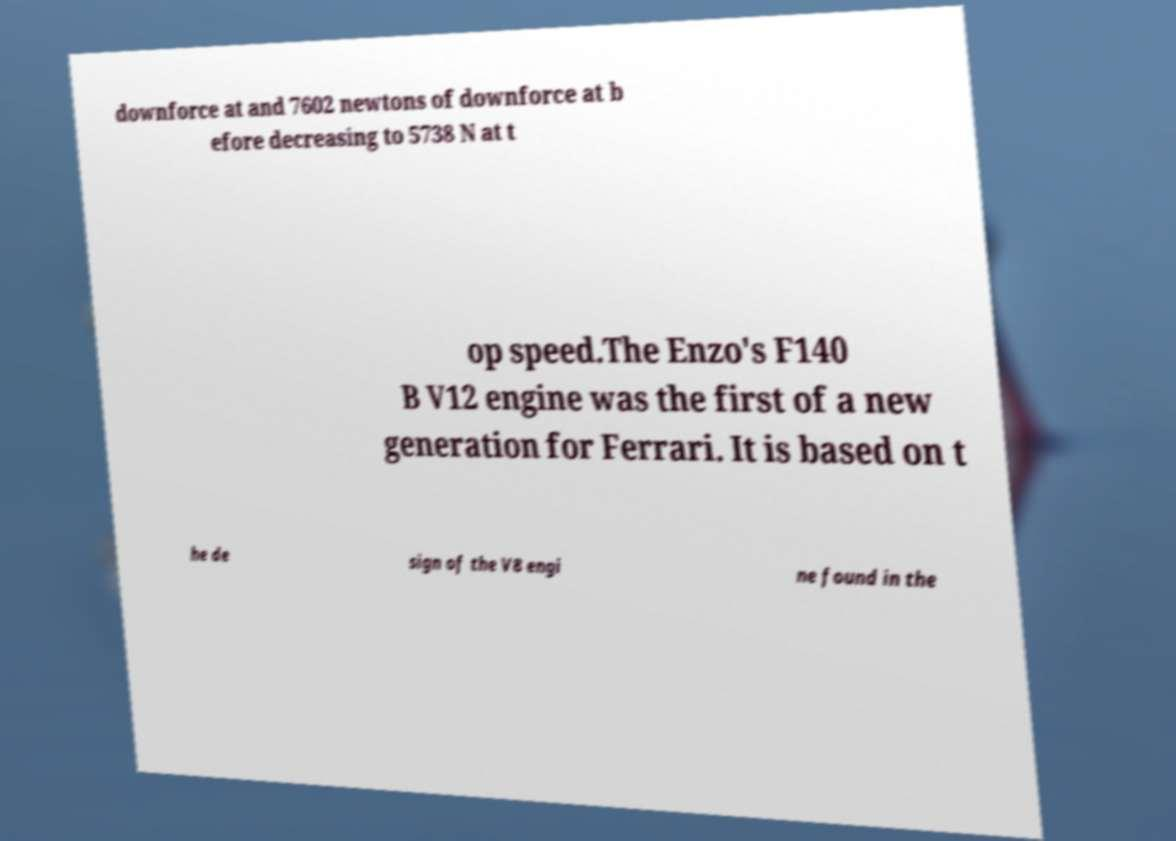There's text embedded in this image that I need extracted. Can you transcribe it verbatim? downforce at and 7602 newtons of downforce at b efore decreasing to 5738 N at t op speed.The Enzo's F140 B V12 engine was the first of a new generation for Ferrari. It is based on t he de sign of the V8 engi ne found in the 